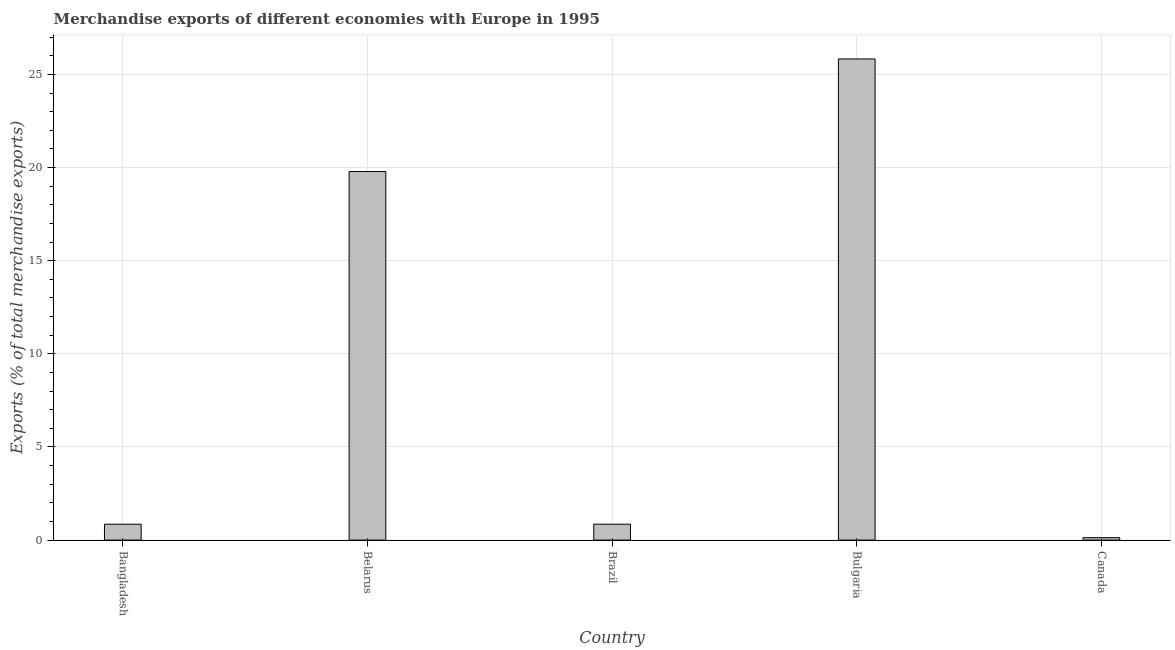Does the graph contain any zero values?
Make the answer very short. No. What is the title of the graph?
Provide a short and direct response. Merchandise exports of different economies with Europe in 1995. What is the label or title of the Y-axis?
Offer a terse response. Exports (% of total merchandise exports). What is the merchandise exports in Bangladesh?
Provide a succinct answer. 0.85. Across all countries, what is the maximum merchandise exports?
Ensure brevity in your answer.  25.83. Across all countries, what is the minimum merchandise exports?
Ensure brevity in your answer.  0.13. In which country was the merchandise exports maximum?
Your answer should be compact. Bulgaria. What is the sum of the merchandise exports?
Offer a terse response. 47.45. What is the difference between the merchandise exports in Bangladesh and Belarus?
Your response must be concise. -18.93. What is the average merchandise exports per country?
Your answer should be very brief. 9.49. What is the median merchandise exports?
Your response must be concise. 0.85. In how many countries, is the merchandise exports greater than 11 %?
Make the answer very short. 2. What is the ratio of the merchandise exports in Belarus to that in Bulgaria?
Your answer should be compact. 0.77. Is the difference between the merchandise exports in Belarus and Bulgaria greater than the difference between any two countries?
Provide a succinct answer. No. What is the difference between the highest and the second highest merchandise exports?
Your answer should be compact. 6.04. Is the sum of the merchandise exports in Belarus and Bulgaria greater than the maximum merchandise exports across all countries?
Make the answer very short. Yes. What is the difference between the highest and the lowest merchandise exports?
Your answer should be very brief. 25.7. In how many countries, is the merchandise exports greater than the average merchandise exports taken over all countries?
Your response must be concise. 2. How many countries are there in the graph?
Your answer should be compact. 5. Are the values on the major ticks of Y-axis written in scientific E-notation?
Provide a succinct answer. No. What is the Exports (% of total merchandise exports) of Bangladesh?
Offer a terse response. 0.85. What is the Exports (% of total merchandise exports) of Belarus?
Your response must be concise. 19.78. What is the Exports (% of total merchandise exports) in Brazil?
Your answer should be very brief. 0.85. What is the Exports (% of total merchandise exports) in Bulgaria?
Provide a succinct answer. 25.83. What is the Exports (% of total merchandise exports) in Canada?
Ensure brevity in your answer.  0.13. What is the difference between the Exports (% of total merchandise exports) in Bangladesh and Belarus?
Your answer should be very brief. -18.93. What is the difference between the Exports (% of total merchandise exports) in Bangladesh and Brazil?
Provide a short and direct response. -0. What is the difference between the Exports (% of total merchandise exports) in Bangladesh and Bulgaria?
Offer a very short reply. -24.98. What is the difference between the Exports (% of total merchandise exports) in Bangladesh and Canada?
Keep it short and to the point. 0.72. What is the difference between the Exports (% of total merchandise exports) in Belarus and Brazil?
Provide a short and direct response. 18.93. What is the difference between the Exports (% of total merchandise exports) in Belarus and Bulgaria?
Offer a very short reply. -6.04. What is the difference between the Exports (% of total merchandise exports) in Belarus and Canada?
Ensure brevity in your answer.  19.65. What is the difference between the Exports (% of total merchandise exports) in Brazil and Bulgaria?
Provide a short and direct response. -24.98. What is the difference between the Exports (% of total merchandise exports) in Brazil and Canada?
Offer a very short reply. 0.72. What is the difference between the Exports (% of total merchandise exports) in Bulgaria and Canada?
Ensure brevity in your answer.  25.7. What is the ratio of the Exports (% of total merchandise exports) in Bangladesh to that in Belarus?
Offer a terse response. 0.04. What is the ratio of the Exports (% of total merchandise exports) in Bangladesh to that in Brazil?
Provide a succinct answer. 1. What is the ratio of the Exports (% of total merchandise exports) in Bangladesh to that in Bulgaria?
Provide a short and direct response. 0.03. What is the ratio of the Exports (% of total merchandise exports) in Bangladesh to that in Canada?
Ensure brevity in your answer.  6.56. What is the ratio of the Exports (% of total merchandise exports) in Belarus to that in Brazil?
Offer a terse response. 23.17. What is the ratio of the Exports (% of total merchandise exports) in Belarus to that in Bulgaria?
Make the answer very short. 0.77. What is the ratio of the Exports (% of total merchandise exports) in Belarus to that in Canada?
Keep it short and to the point. 152.26. What is the ratio of the Exports (% of total merchandise exports) in Brazil to that in Bulgaria?
Offer a very short reply. 0.03. What is the ratio of the Exports (% of total merchandise exports) in Brazil to that in Canada?
Provide a succinct answer. 6.57. What is the ratio of the Exports (% of total merchandise exports) in Bulgaria to that in Canada?
Provide a short and direct response. 198.78. 